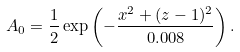Convert formula to latex. <formula><loc_0><loc_0><loc_500><loc_500>A _ { 0 } = \frac { 1 } { 2 } \exp \left ( - \frac { x ^ { 2 } + ( z - 1 ) ^ { 2 } } { 0 . 0 0 8 } \right ) .</formula> 